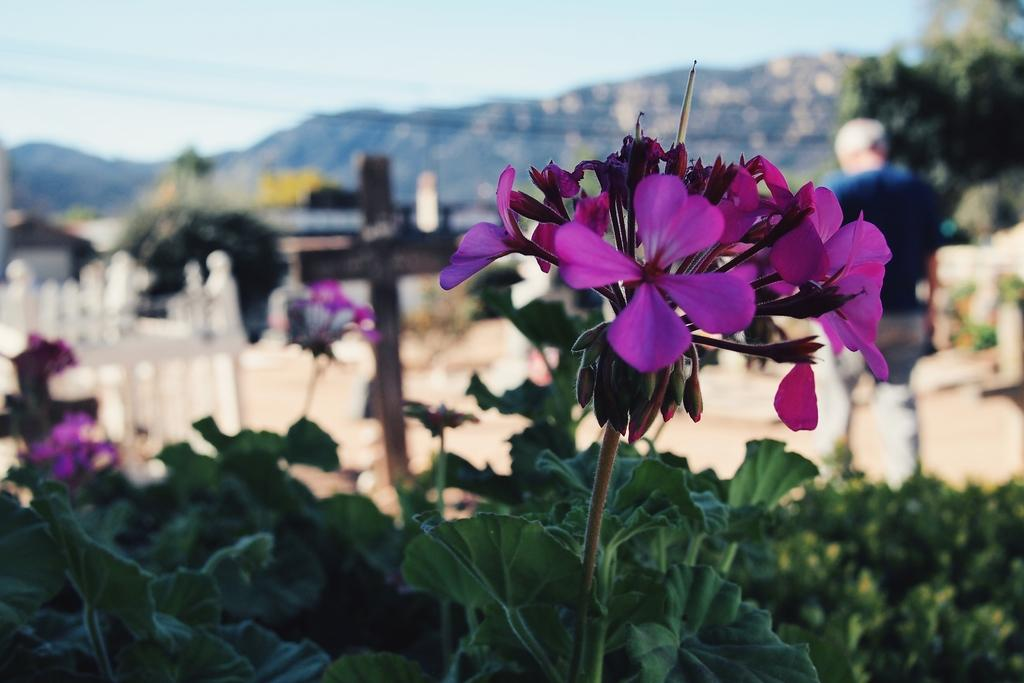What types of vegetation can be seen in the image? There are plants, flowers, and trees in the image. Can you describe the person in the image? There is a person wearing a blue dress in the image, and they are standing. What is visible in the background of the image? There are trees in the background of the image. What is visible at the top of the image? The sky is visible at the top of the image. What types of toys can be seen in the image? There are no toys present in the image. Is the person's father visible in the image? There is no information about the person's father in the image. What type of education is being pursued by the person in the image? There is no information about the person's education in the image. 